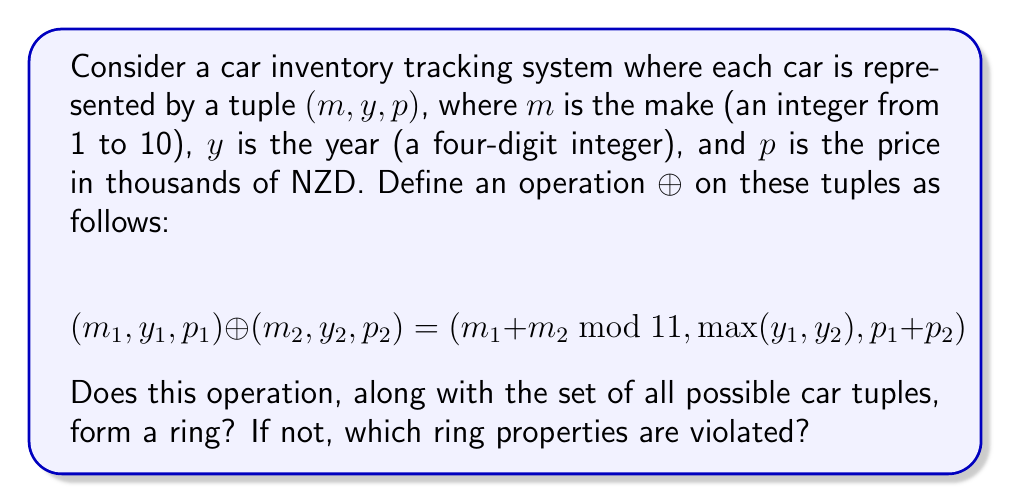What is the answer to this math problem? To determine if this structure forms a ring, we need to check the ring axioms:

1. Closure under addition ($\oplus$):
   The operation is closed as it always produces another valid tuple.

2. Associativity of addition:
   $((a \oplus b) \oplus c) = (a \oplus (b \oplus c))$ for all elements $a, b, c$.
   This holds for each component of the tuple.

3. Commutativity of addition:
   $a \oplus b = b \oplus a$ for all elements $a, b$.
   This holds as addition modulo 11, max, and regular addition are all commutative.

4. Additive identity:
   The element $(0, 0, 0)$ serves as the additive identity.

5. Additive inverse:
   For any $(m, y, p)$, the inverse would be $(11-m \mod 11, 0, -p)$.
   However, this is problematic as the year cannot be negative in our context.

6. Closure under multiplication:
   There is no defined multiplication operation.

7. Associativity of multiplication:
   Cannot be checked without a multiplication operation.

8. Distributivity:
   Cannot be checked without a multiplication operation.

The structure fails to be a ring primarily because:
1. It lacks additive inverses for all elements (the year component cannot be negated).
2. There is no defined multiplication operation.
Answer: No, this structure does not form a ring. It violates the additive inverse property and lacks a multiplication operation, which are both necessary for a ring structure. 